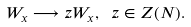Convert formula to latex. <formula><loc_0><loc_0><loc_500><loc_500>W _ { x } \longrightarrow z W _ { x } , \ z \in Z ( N ) .</formula> 